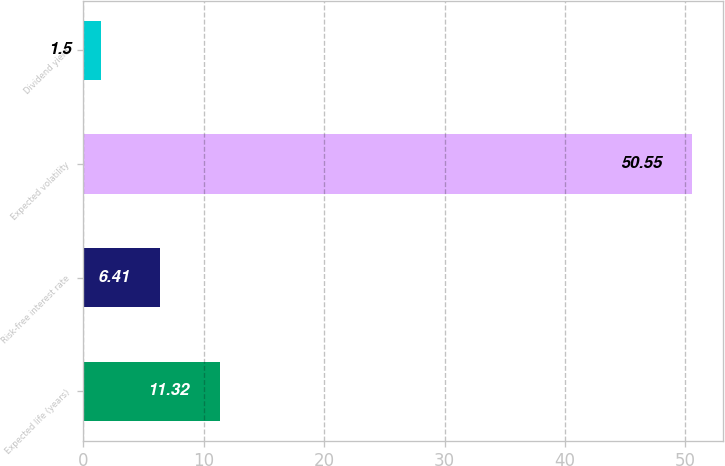<chart> <loc_0><loc_0><loc_500><loc_500><bar_chart><fcel>Expected life (years)<fcel>Risk-free interest rate<fcel>Expected volatility<fcel>Dividend yield<nl><fcel>11.32<fcel>6.41<fcel>50.55<fcel>1.5<nl></chart> 